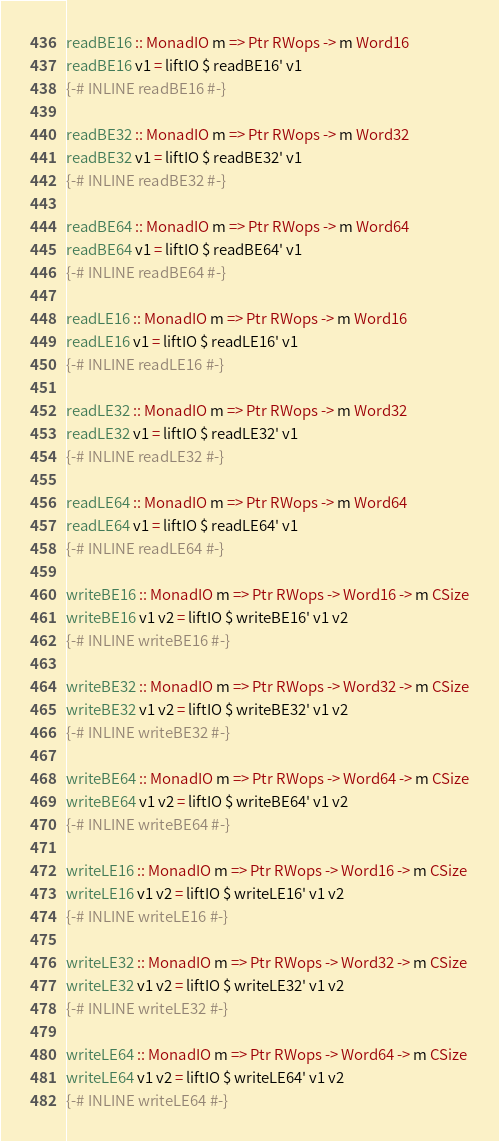<code> <loc_0><loc_0><loc_500><loc_500><_Haskell_>readBE16 :: MonadIO m => Ptr RWops -> m Word16
readBE16 v1 = liftIO $ readBE16' v1
{-# INLINE readBE16 #-}

readBE32 :: MonadIO m => Ptr RWops -> m Word32
readBE32 v1 = liftIO $ readBE32' v1
{-# INLINE readBE32 #-}

readBE64 :: MonadIO m => Ptr RWops -> m Word64
readBE64 v1 = liftIO $ readBE64' v1
{-# INLINE readBE64 #-}

readLE16 :: MonadIO m => Ptr RWops -> m Word16
readLE16 v1 = liftIO $ readLE16' v1
{-# INLINE readLE16 #-}

readLE32 :: MonadIO m => Ptr RWops -> m Word32
readLE32 v1 = liftIO $ readLE32' v1
{-# INLINE readLE32 #-}

readLE64 :: MonadIO m => Ptr RWops -> m Word64
readLE64 v1 = liftIO $ readLE64' v1
{-# INLINE readLE64 #-}

writeBE16 :: MonadIO m => Ptr RWops -> Word16 -> m CSize
writeBE16 v1 v2 = liftIO $ writeBE16' v1 v2
{-# INLINE writeBE16 #-}

writeBE32 :: MonadIO m => Ptr RWops -> Word32 -> m CSize
writeBE32 v1 v2 = liftIO $ writeBE32' v1 v2
{-# INLINE writeBE32 #-}

writeBE64 :: MonadIO m => Ptr RWops -> Word64 -> m CSize
writeBE64 v1 v2 = liftIO $ writeBE64' v1 v2
{-# INLINE writeBE64 #-}

writeLE16 :: MonadIO m => Ptr RWops -> Word16 -> m CSize
writeLE16 v1 v2 = liftIO $ writeLE16' v1 v2
{-# INLINE writeLE16 #-}

writeLE32 :: MonadIO m => Ptr RWops -> Word32 -> m CSize
writeLE32 v1 v2 = liftIO $ writeLE32' v1 v2
{-# INLINE writeLE32 #-}

writeLE64 :: MonadIO m => Ptr RWops -> Word64 -> m CSize
writeLE64 v1 v2 = liftIO $ writeLE64' v1 v2
{-# INLINE writeLE64 #-}
</code> 